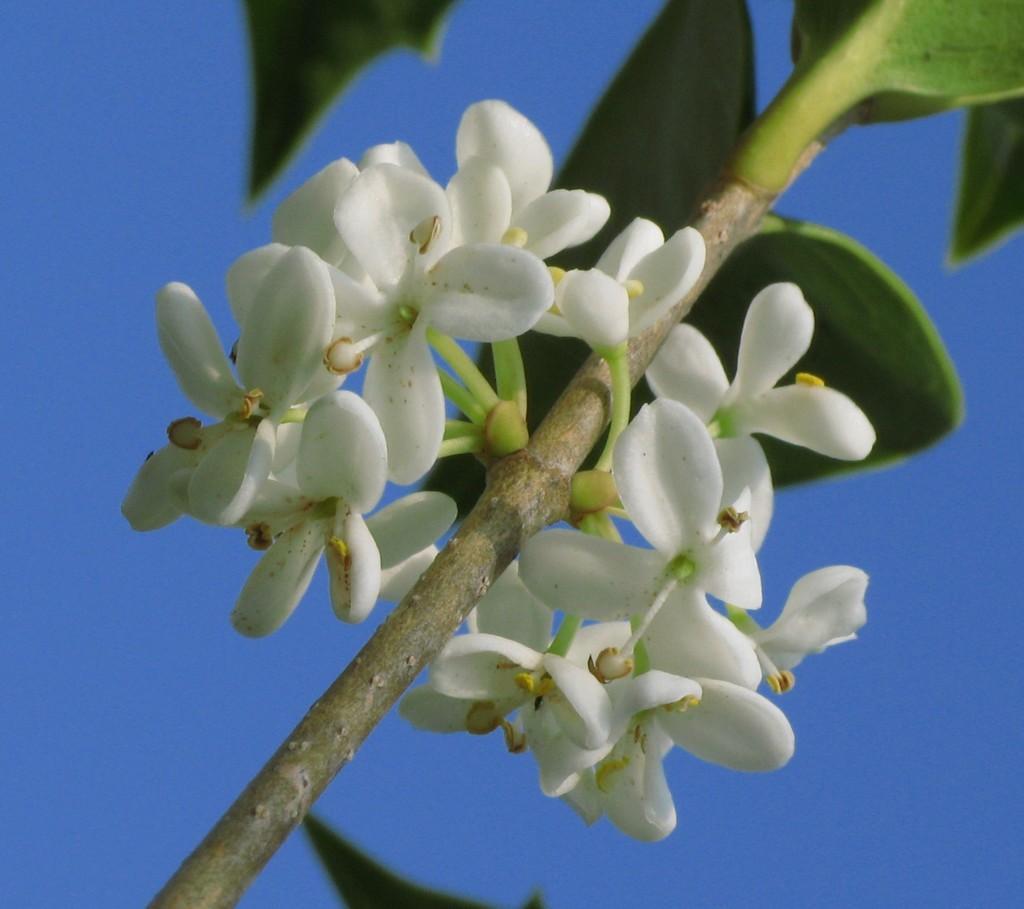Can you describe this image briefly? In the image in the center we can see one plant and few flowers,which are in white color. In the background we can see the sky. 